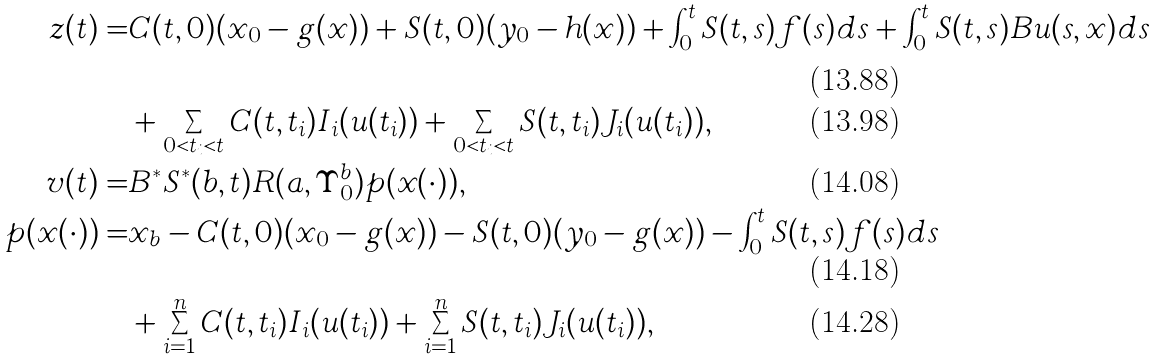<formula> <loc_0><loc_0><loc_500><loc_500>z ( t ) = & C ( t , 0 ) ( x _ { 0 } - g ( x ) ) + S ( t , 0 ) ( y _ { 0 } - h ( x ) ) + \int _ { 0 } ^ { t } S ( t , s ) f ( s ) d s + \int _ { 0 } ^ { t } S ( t , s ) B u ( s , x ) d s \\ & + \sum _ { 0 < t _ { i } < t } C ( t , t _ { i } ) I _ { i } ( u ( t _ { i } ) ) + \sum _ { 0 < t _ { i } < t } S ( t , t _ { i } ) J _ { i } ( u ( t _ { i } ) ) , \\ v ( t ) = & B ^ { * } S ^ { * } ( b , t ) R ( a , \Upsilon _ { 0 } ^ { b } ) p ( x ( \cdot ) ) , \\ p ( x ( \cdot ) ) = & x _ { b } - C ( t , 0 ) ( x _ { 0 } - g ( x ) ) - S ( t , 0 ) ( y _ { 0 } - g ( x ) ) - \int _ { 0 } ^ { t } S ( t , s ) f ( s ) d s \\ & + \sum _ { i = 1 } ^ { n } C ( t , t _ { i } ) I _ { i } ( u ( t _ { i } ) ) + \sum _ { i = 1 } ^ { n } S ( t , t _ { i } ) J _ { i } ( u ( t _ { i } ) ) ,</formula> 